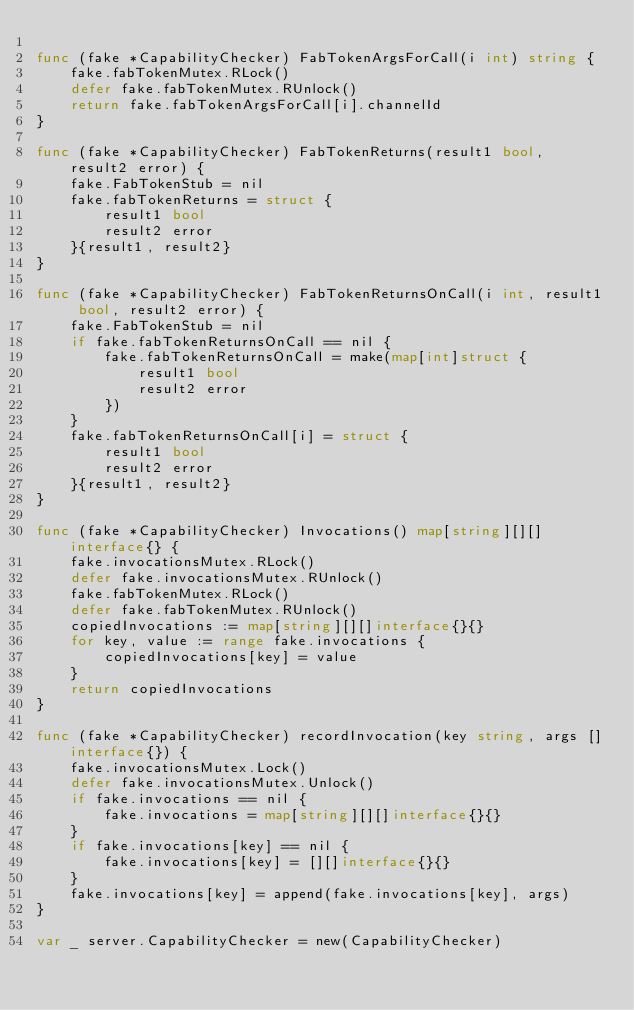Convert code to text. <code><loc_0><loc_0><loc_500><loc_500><_Go_>
func (fake *CapabilityChecker) FabTokenArgsForCall(i int) string {
	fake.fabTokenMutex.RLock()
	defer fake.fabTokenMutex.RUnlock()
	return fake.fabTokenArgsForCall[i].channelId
}

func (fake *CapabilityChecker) FabTokenReturns(result1 bool, result2 error) {
	fake.FabTokenStub = nil
	fake.fabTokenReturns = struct {
		result1 bool
		result2 error
	}{result1, result2}
}

func (fake *CapabilityChecker) FabTokenReturnsOnCall(i int, result1 bool, result2 error) {
	fake.FabTokenStub = nil
	if fake.fabTokenReturnsOnCall == nil {
		fake.fabTokenReturnsOnCall = make(map[int]struct {
			result1 bool
			result2 error
		})
	}
	fake.fabTokenReturnsOnCall[i] = struct {
		result1 bool
		result2 error
	}{result1, result2}
}

func (fake *CapabilityChecker) Invocations() map[string][][]interface{} {
	fake.invocationsMutex.RLock()
	defer fake.invocationsMutex.RUnlock()
	fake.fabTokenMutex.RLock()
	defer fake.fabTokenMutex.RUnlock()
	copiedInvocations := map[string][][]interface{}{}
	for key, value := range fake.invocations {
		copiedInvocations[key] = value
	}
	return copiedInvocations
}

func (fake *CapabilityChecker) recordInvocation(key string, args []interface{}) {
	fake.invocationsMutex.Lock()
	defer fake.invocationsMutex.Unlock()
	if fake.invocations == nil {
		fake.invocations = map[string][][]interface{}{}
	}
	if fake.invocations[key] == nil {
		fake.invocations[key] = [][]interface{}{}
	}
	fake.invocations[key] = append(fake.invocations[key], args)
}

var _ server.CapabilityChecker = new(CapabilityChecker)
</code> 